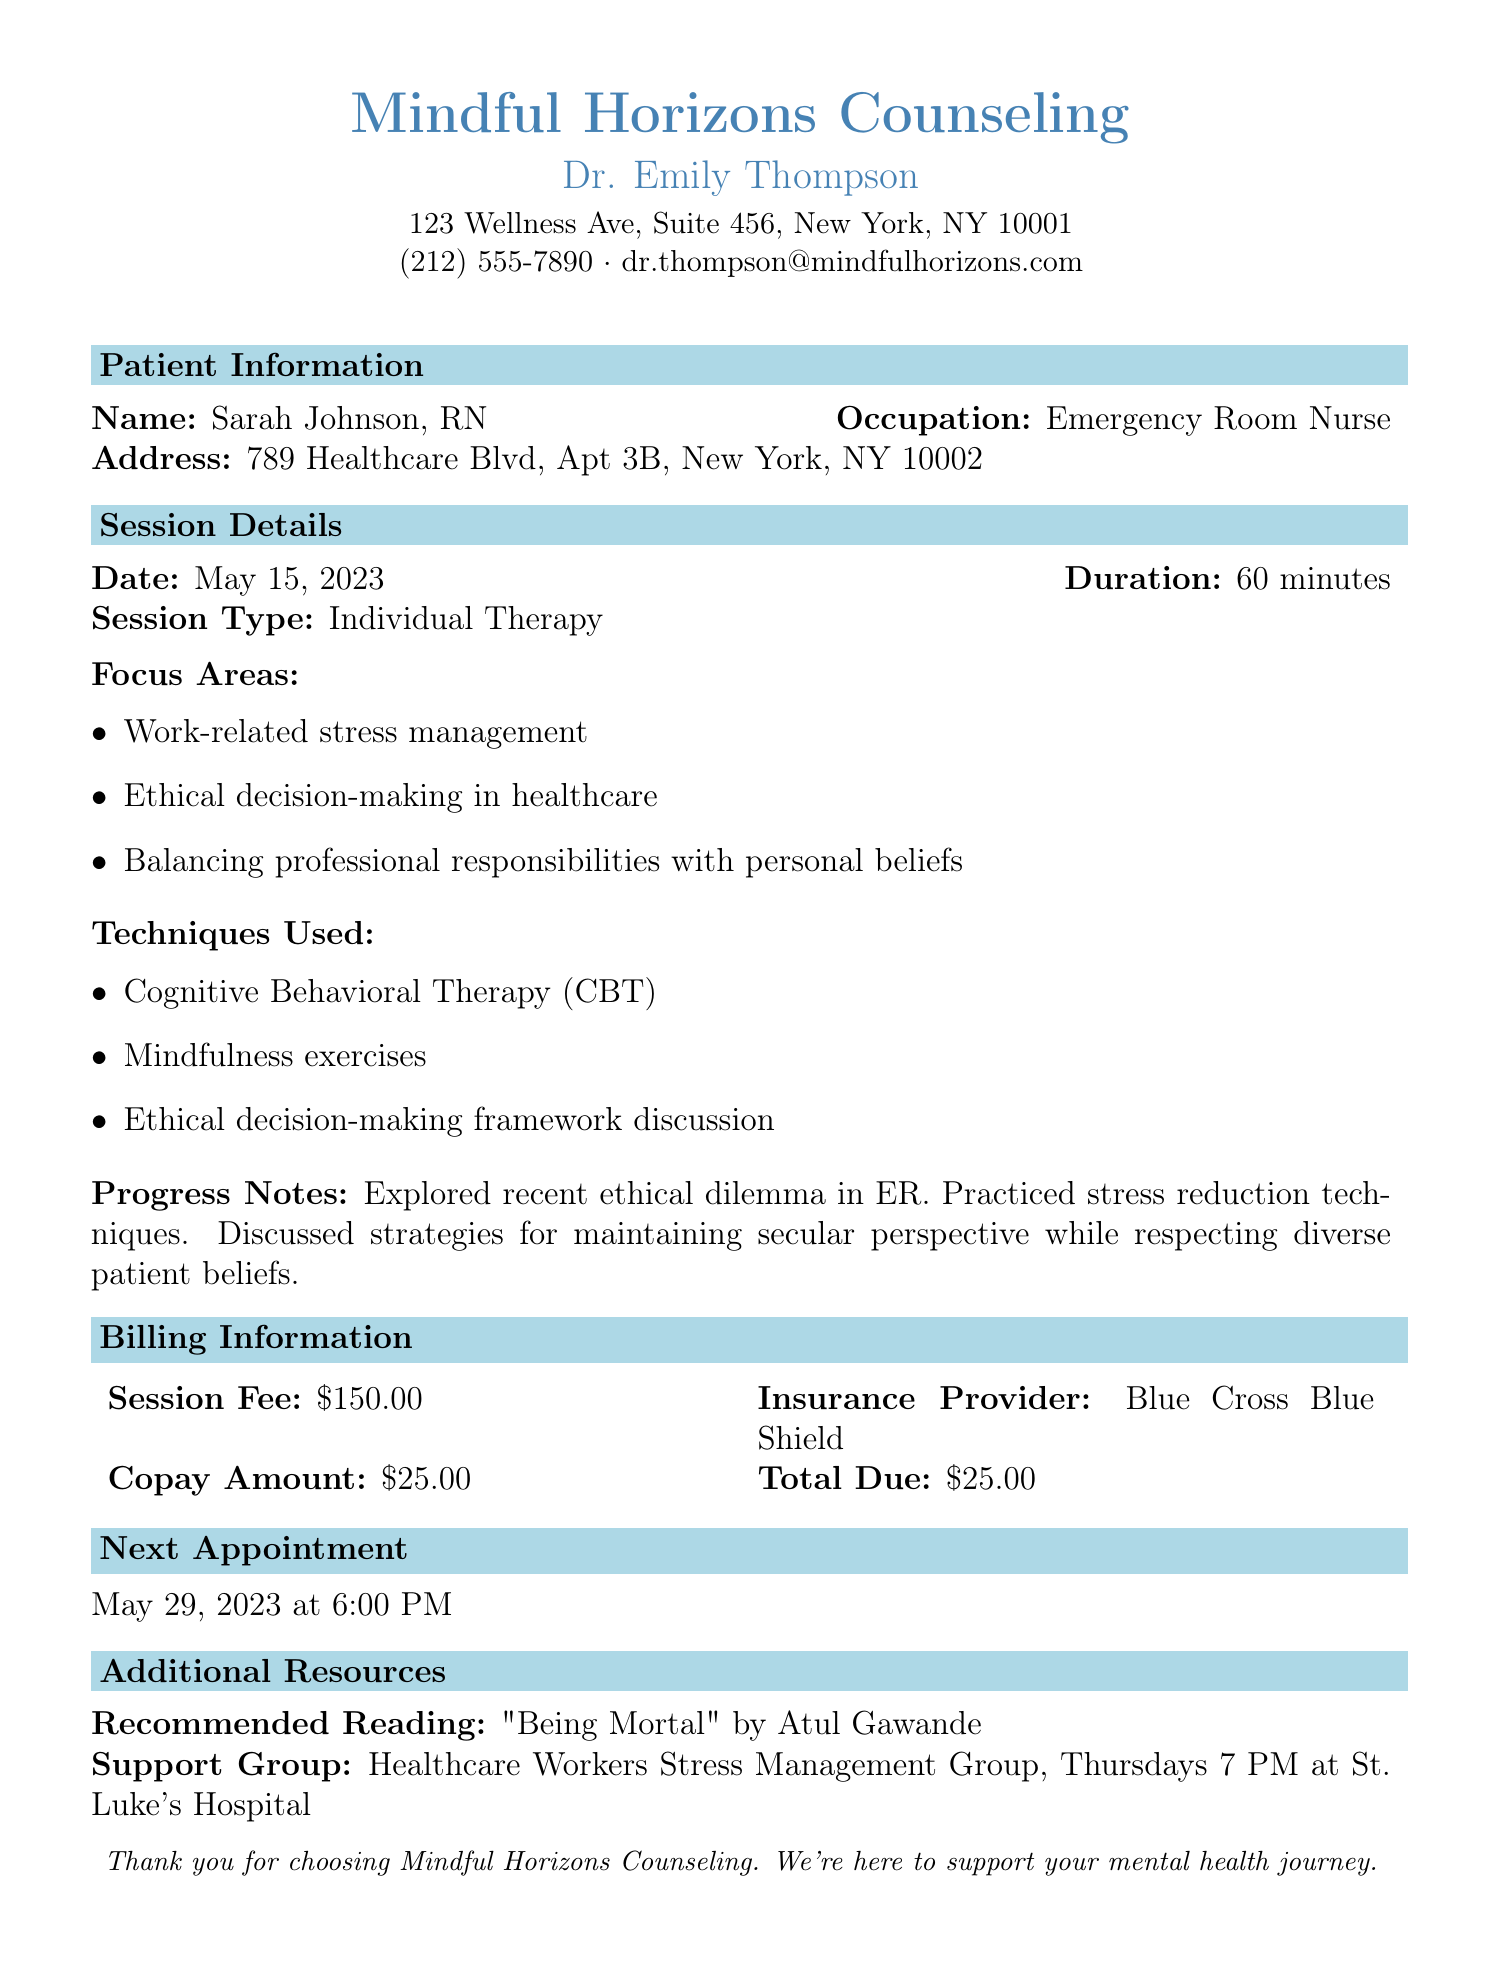What is the name of the therapist? The therapist's name is listed at the top of the document under "Mindful Horizons Counseling."
Answer: Dr. Emily Thompson What was the date of the therapy session? The date of the session is specifically mentioned in the "Session Details" section.
Answer: May 15, 2023 What is the total amount due after insurance? The total amount due is calculated based on the session fee and copay listed in the "Billing Information" section.
Answer: $25.00 What techniques were used in the therapy session? The techniques used during the session are outlined in the "Techniques Used" section.
Answer: Cognitive Behavioral Therapy (CBT), Mindfulness exercises, Ethical decision-making framework discussion What are the focus areas of the therapy session? The focus areas are listed in the "Focus Areas" section of the document.
Answer: Work-related stress management, Ethical decision-making in healthcare, Balancing professional responsibilities with personal beliefs When is the next appointment scheduled? The next appointment date and time are outlined in the "Next Appointment" section.
Answer: May 29, 2023 at 6:00 PM What is the recommended reading? The recommended reading is provided in the "Additional Resources" section.
Answer: "Being Mortal" by Atul Gawande What support group is mentioned? The support group details are provided in the "Additional Resources" section, specifying its name and meeting time.
Answer: Healthcare Workers Stress Management Group, Thursdays 7 PM at St. Luke's Hospital 